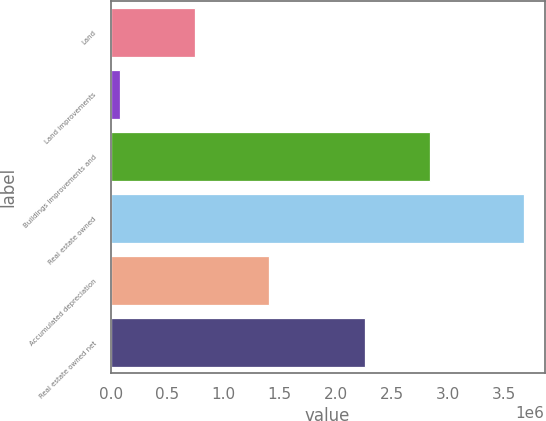<chart> <loc_0><loc_0><loc_500><loc_500><bar_chart><fcel>Land<fcel>Land improvements<fcel>Buildings improvements and<fcel>Real estate owned<fcel>Accumulated depreciation<fcel>Real estate owned net<nl><fcel>751981<fcel>84663<fcel>2.83806e+06<fcel>3.6747e+06<fcel>1.40882e+06<fcel>2.26589e+06<nl></chart> 